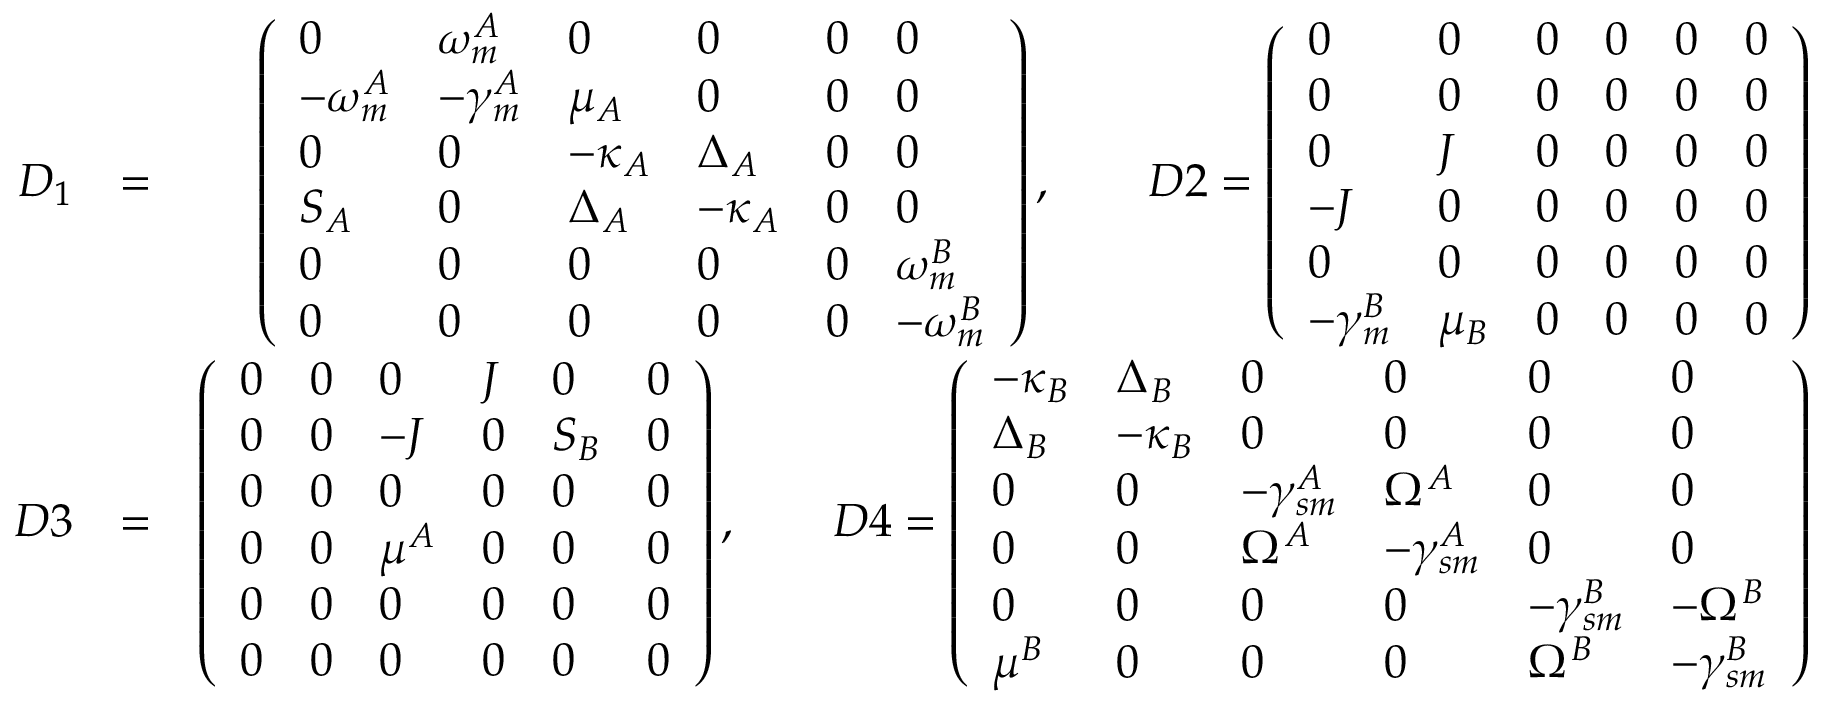<formula> <loc_0><loc_0><loc_500><loc_500>\begin{array} { r l r } { D _ { 1 } } & { = } & { \left ( \begin{array} { l l l l l l } { 0 } & { \omega _ { m } ^ { A } } & { 0 } & { 0 } & { 0 } & { 0 } \\ { - \omega _ { m } ^ { A } } & { - \gamma _ { m } ^ { A } } & { \mu _ { A } } & { 0 } & { 0 } & { 0 } \\ { 0 } & { 0 } & { - \kappa _ { A } } & { \Delta _ { A } } & { 0 } & { 0 } \\ { S _ { A } } & { 0 } & { \Delta _ { A } } & { - \kappa _ { A } } & { 0 } & { 0 } \\ { 0 } & { 0 } & { 0 } & { 0 } & { 0 } & { \omega _ { m } ^ { B } } \\ { 0 } & { 0 } & { 0 } & { 0 } & { 0 } & { - \omega _ { m } ^ { B } } \end{array} \right ) , \quad D 2 = \left ( \begin{array} { l l l l l l } { 0 } & { 0 } & { 0 } & { 0 } & { 0 } & { 0 } \\ { 0 } & { 0 } & { 0 } & { 0 } & { 0 } & { 0 } \\ { 0 } & { J } & { 0 } & { 0 } & { 0 } & { 0 } \\ { - J } & { 0 } & { 0 } & { 0 } & { 0 } & { 0 } \\ { 0 } & { 0 } & { 0 } & { 0 } & { 0 } & { 0 } \\ { - \gamma _ { m } ^ { B } } & { \mu _ { B } } & { 0 } & { 0 } & { 0 } & { 0 } \end{array} \right ) } \\ { D 3 } & { = } & { \left ( \begin{array} { l l l l l l } { 0 } & { 0 } & { 0 } & { J } & { 0 } & { 0 } \\ { 0 } & { 0 } & { - J } & { 0 } & { S _ { B } } & { 0 } \\ { 0 } & { 0 } & { 0 } & { 0 } & { 0 } & { 0 } \\ { 0 } & { 0 } & { \mu ^ { A } } & { 0 } & { 0 } & { 0 } \\ { 0 } & { 0 } & { 0 } & { 0 } & { 0 } & { 0 } \\ { 0 } & { 0 } & { 0 } & { 0 } & { 0 } & { 0 } \end{array} \right ) , \quad D 4 = \left ( \begin{array} { l l l l l l } { - \kappa _ { B } } & { \Delta _ { B } } & { 0 } & { 0 } & { 0 } & { 0 } \\ { \Delta _ { B } } & { - \kappa _ { B } } & { 0 } & { 0 } & { 0 } & { 0 } \\ { 0 } & { 0 } & { - \gamma _ { s m } ^ { A } } & { \Omega ^ { A } } & { 0 } & { 0 } \\ { 0 } & { 0 } & { \Omega ^ { A } } & { - \gamma _ { s m } ^ { A } } & { 0 } & { 0 } \\ { 0 } & { 0 } & { 0 } & { 0 } & { - \gamma _ { s m } ^ { B } } & { - \Omega ^ { B } } \\ { \mu ^ { B } } & { 0 } & { 0 } & { 0 } & { \Omega ^ { B } } & { - \gamma _ { s m } ^ { B } } \end{array} \right ) } \end{array}</formula> 